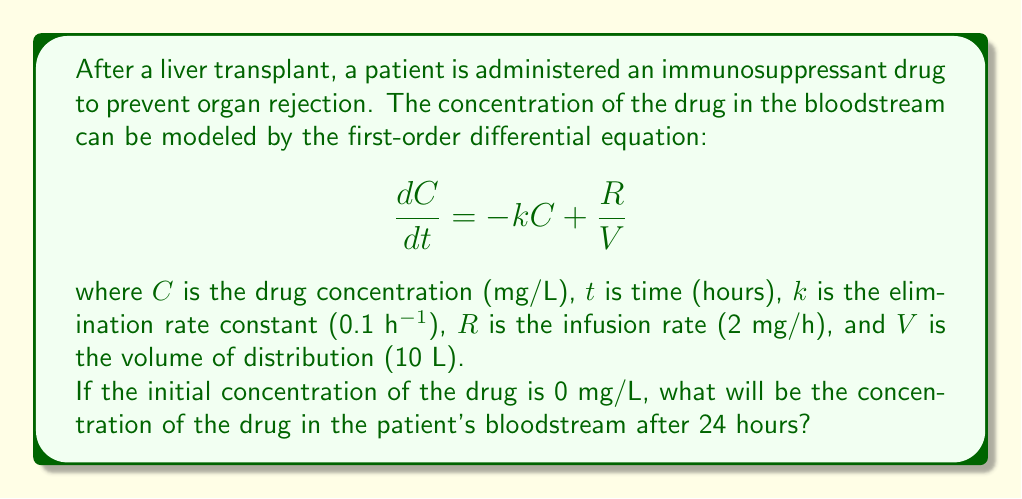Can you solve this math problem? To solve this first-order differential equation, we follow these steps:

1) The general solution for this type of differential equation is:

   $$C(t) = C_e + (C_0 - C_e)e^{-kt}$$

   where $C_e$ is the equilibrium concentration and $C_0$ is the initial concentration.

2) The equilibrium concentration $C_e$ can be found by setting $\frac{dC}{dt} = 0$:

   $$0 = -kC_e + \frac{R}{V}$$
   $$C_e = \frac{R}{kV} = \frac{2}{0.1 * 10} = 2 \text{ mg/L}$$

3) We're given that the initial concentration $C_0 = 0$ mg/L.

4) Substituting these values into the general solution:

   $$C(t) = 2 + (0 - 2)e^{-0.1t}$$
   $$C(t) = 2 - 2e^{-0.1t}$$

5) To find the concentration after 24 hours, we substitute $t = 24$:

   $$C(24) = 2 - 2e^{-0.1 * 24}$$
   $$C(24) = 2 - 2e^{-2.4}$$
   $$C(24) = 2 - 2 * 0.0907$$
   $$C(24) = 1.8186 \text{ mg/L}$$

Therefore, after 24 hours, the drug concentration in the patient's bloodstream will be approximately 1.8186 mg/L.
Answer: 1.8186 mg/L 